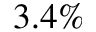<formula> <loc_0><loc_0><loc_500><loc_500>3 . 4 \%</formula> 